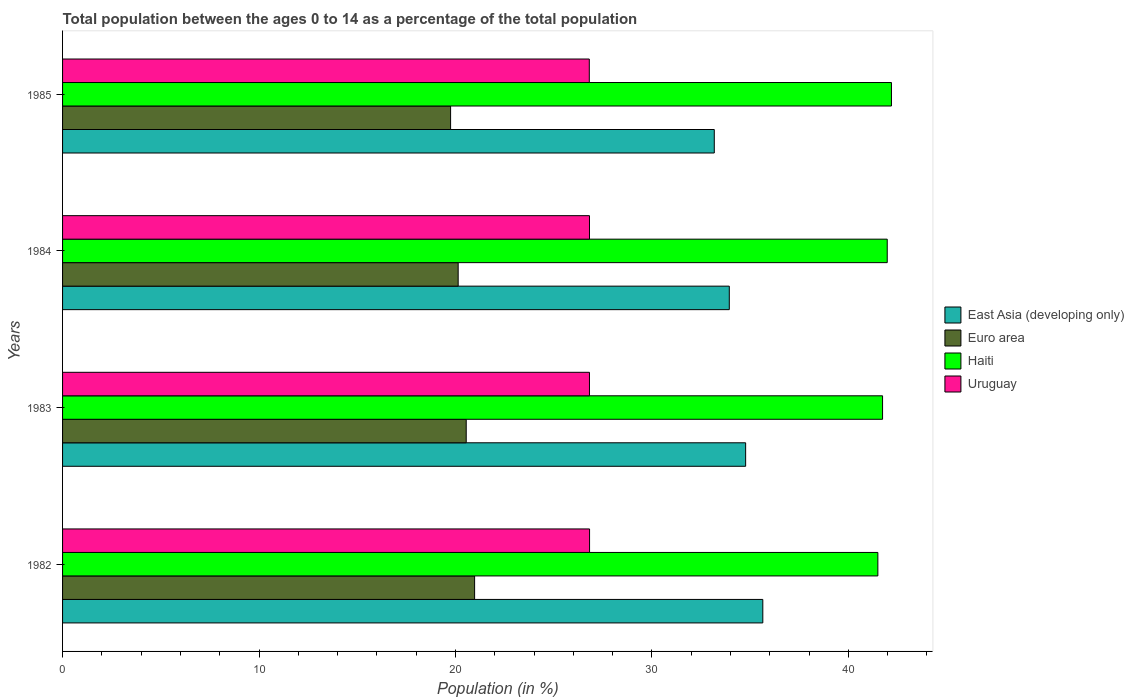How many different coloured bars are there?
Provide a succinct answer. 4. Are the number of bars per tick equal to the number of legend labels?
Your answer should be very brief. Yes. Are the number of bars on each tick of the Y-axis equal?
Offer a very short reply. Yes. How many bars are there on the 3rd tick from the bottom?
Give a very brief answer. 4. In how many cases, is the number of bars for a given year not equal to the number of legend labels?
Your answer should be very brief. 0. What is the percentage of the population ages 0 to 14 in Haiti in 1985?
Give a very brief answer. 42.2. Across all years, what is the maximum percentage of the population ages 0 to 14 in Euro area?
Offer a terse response. 20.98. Across all years, what is the minimum percentage of the population ages 0 to 14 in Uruguay?
Ensure brevity in your answer.  26.81. In which year was the percentage of the population ages 0 to 14 in East Asia (developing only) minimum?
Offer a very short reply. 1985. What is the total percentage of the population ages 0 to 14 in Haiti in the graph?
Your answer should be very brief. 167.42. What is the difference between the percentage of the population ages 0 to 14 in East Asia (developing only) in 1982 and that in 1985?
Your answer should be very brief. 2.47. What is the difference between the percentage of the population ages 0 to 14 in Euro area in 1983 and the percentage of the population ages 0 to 14 in East Asia (developing only) in 1982?
Offer a very short reply. -15.1. What is the average percentage of the population ages 0 to 14 in Uruguay per year?
Provide a short and direct response. 26.82. In the year 1984, what is the difference between the percentage of the population ages 0 to 14 in Euro area and percentage of the population ages 0 to 14 in Haiti?
Offer a very short reply. -21.84. In how many years, is the percentage of the population ages 0 to 14 in East Asia (developing only) greater than 16 ?
Provide a short and direct response. 4. What is the ratio of the percentage of the population ages 0 to 14 in Euro area in 1984 to that in 1985?
Provide a succinct answer. 1.02. What is the difference between the highest and the second highest percentage of the population ages 0 to 14 in East Asia (developing only)?
Your answer should be very brief. 0.87. What is the difference between the highest and the lowest percentage of the population ages 0 to 14 in Euro area?
Give a very brief answer. 1.22. In how many years, is the percentage of the population ages 0 to 14 in East Asia (developing only) greater than the average percentage of the population ages 0 to 14 in East Asia (developing only) taken over all years?
Give a very brief answer. 2. Is the sum of the percentage of the population ages 0 to 14 in Haiti in 1983 and 1985 greater than the maximum percentage of the population ages 0 to 14 in Uruguay across all years?
Offer a terse response. Yes. Is it the case that in every year, the sum of the percentage of the population ages 0 to 14 in East Asia (developing only) and percentage of the population ages 0 to 14 in Euro area is greater than the sum of percentage of the population ages 0 to 14 in Haiti and percentage of the population ages 0 to 14 in Uruguay?
Give a very brief answer. No. What does the 1st bar from the bottom in 1983 represents?
Keep it short and to the point. East Asia (developing only). Is it the case that in every year, the sum of the percentage of the population ages 0 to 14 in Haiti and percentage of the population ages 0 to 14 in Euro area is greater than the percentage of the population ages 0 to 14 in Uruguay?
Provide a short and direct response. Yes. How many bars are there?
Your answer should be compact. 16. What is the difference between two consecutive major ticks on the X-axis?
Your answer should be compact. 10. Does the graph contain any zero values?
Your response must be concise. No. Does the graph contain grids?
Give a very brief answer. No. Where does the legend appear in the graph?
Offer a terse response. Center right. What is the title of the graph?
Keep it short and to the point. Total population between the ages 0 to 14 as a percentage of the total population. Does "Denmark" appear as one of the legend labels in the graph?
Your response must be concise. No. What is the label or title of the X-axis?
Provide a short and direct response. Population (in %). What is the label or title of the Y-axis?
Keep it short and to the point. Years. What is the Population (in %) in East Asia (developing only) in 1982?
Make the answer very short. 35.65. What is the Population (in %) of Euro area in 1982?
Provide a short and direct response. 20.98. What is the Population (in %) of Haiti in 1982?
Give a very brief answer. 41.5. What is the Population (in %) of Uruguay in 1982?
Provide a succinct answer. 26.83. What is the Population (in %) of East Asia (developing only) in 1983?
Provide a short and direct response. 34.77. What is the Population (in %) in Euro area in 1983?
Your response must be concise. 20.55. What is the Population (in %) in Haiti in 1983?
Your answer should be very brief. 41.74. What is the Population (in %) in Uruguay in 1983?
Keep it short and to the point. 26.82. What is the Population (in %) in East Asia (developing only) in 1984?
Make the answer very short. 33.94. What is the Population (in %) of Euro area in 1984?
Your response must be concise. 20.14. What is the Population (in %) of Haiti in 1984?
Make the answer very short. 41.98. What is the Population (in %) of Uruguay in 1984?
Your answer should be very brief. 26.82. What is the Population (in %) in East Asia (developing only) in 1985?
Offer a terse response. 33.18. What is the Population (in %) in Euro area in 1985?
Make the answer very short. 19.75. What is the Population (in %) in Haiti in 1985?
Offer a very short reply. 42.2. What is the Population (in %) in Uruguay in 1985?
Ensure brevity in your answer.  26.81. Across all years, what is the maximum Population (in %) of East Asia (developing only)?
Your answer should be compact. 35.65. Across all years, what is the maximum Population (in %) of Euro area?
Offer a very short reply. 20.98. Across all years, what is the maximum Population (in %) of Haiti?
Your answer should be compact. 42.2. Across all years, what is the maximum Population (in %) in Uruguay?
Offer a terse response. 26.83. Across all years, what is the minimum Population (in %) in East Asia (developing only)?
Keep it short and to the point. 33.18. Across all years, what is the minimum Population (in %) in Euro area?
Provide a short and direct response. 19.75. Across all years, what is the minimum Population (in %) in Haiti?
Your answer should be very brief. 41.5. Across all years, what is the minimum Population (in %) in Uruguay?
Make the answer very short. 26.81. What is the total Population (in %) of East Asia (developing only) in the graph?
Offer a very short reply. 137.54. What is the total Population (in %) of Euro area in the graph?
Make the answer very short. 81.42. What is the total Population (in %) in Haiti in the graph?
Your answer should be compact. 167.42. What is the total Population (in %) in Uruguay in the graph?
Keep it short and to the point. 107.29. What is the difference between the Population (in %) in East Asia (developing only) in 1982 and that in 1983?
Make the answer very short. 0.87. What is the difference between the Population (in %) in Euro area in 1982 and that in 1983?
Provide a short and direct response. 0.43. What is the difference between the Population (in %) of Haiti in 1982 and that in 1983?
Your response must be concise. -0.24. What is the difference between the Population (in %) of Uruguay in 1982 and that in 1983?
Provide a succinct answer. 0.01. What is the difference between the Population (in %) in East Asia (developing only) in 1982 and that in 1984?
Offer a terse response. 1.71. What is the difference between the Population (in %) in Euro area in 1982 and that in 1984?
Keep it short and to the point. 0.84. What is the difference between the Population (in %) of Haiti in 1982 and that in 1984?
Your answer should be very brief. -0.48. What is the difference between the Population (in %) in Uruguay in 1982 and that in 1984?
Your response must be concise. 0. What is the difference between the Population (in %) in East Asia (developing only) in 1982 and that in 1985?
Ensure brevity in your answer.  2.47. What is the difference between the Population (in %) in Euro area in 1982 and that in 1985?
Provide a succinct answer. 1.22. What is the difference between the Population (in %) of Haiti in 1982 and that in 1985?
Provide a short and direct response. -0.69. What is the difference between the Population (in %) of Uruguay in 1982 and that in 1985?
Your response must be concise. 0.01. What is the difference between the Population (in %) of East Asia (developing only) in 1983 and that in 1984?
Keep it short and to the point. 0.83. What is the difference between the Population (in %) in Euro area in 1983 and that in 1984?
Keep it short and to the point. 0.41. What is the difference between the Population (in %) in Haiti in 1983 and that in 1984?
Your answer should be very brief. -0.24. What is the difference between the Population (in %) of Uruguay in 1983 and that in 1984?
Provide a succinct answer. -0. What is the difference between the Population (in %) of East Asia (developing only) in 1983 and that in 1985?
Your response must be concise. 1.6. What is the difference between the Population (in %) of Euro area in 1983 and that in 1985?
Your response must be concise. 0.8. What is the difference between the Population (in %) of Haiti in 1983 and that in 1985?
Offer a very short reply. -0.45. What is the difference between the Population (in %) of Uruguay in 1983 and that in 1985?
Make the answer very short. 0.01. What is the difference between the Population (in %) of East Asia (developing only) in 1984 and that in 1985?
Offer a very short reply. 0.76. What is the difference between the Population (in %) of Euro area in 1984 and that in 1985?
Keep it short and to the point. 0.39. What is the difference between the Population (in %) in Haiti in 1984 and that in 1985?
Provide a short and direct response. -0.21. What is the difference between the Population (in %) in Uruguay in 1984 and that in 1985?
Offer a very short reply. 0.01. What is the difference between the Population (in %) of East Asia (developing only) in 1982 and the Population (in %) of Euro area in 1983?
Make the answer very short. 15.1. What is the difference between the Population (in %) of East Asia (developing only) in 1982 and the Population (in %) of Haiti in 1983?
Give a very brief answer. -6.1. What is the difference between the Population (in %) of East Asia (developing only) in 1982 and the Population (in %) of Uruguay in 1983?
Offer a very short reply. 8.82. What is the difference between the Population (in %) in Euro area in 1982 and the Population (in %) in Haiti in 1983?
Ensure brevity in your answer.  -20.77. What is the difference between the Population (in %) of Euro area in 1982 and the Population (in %) of Uruguay in 1983?
Give a very brief answer. -5.85. What is the difference between the Population (in %) of Haiti in 1982 and the Population (in %) of Uruguay in 1983?
Offer a terse response. 14.68. What is the difference between the Population (in %) in East Asia (developing only) in 1982 and the Population (in %) in Euro area in 1984?
Your answer should be compact. 15.51. What is the difference between the Population (in %) in East Asia (developing only) in 1982 and the Population (in %) in Haiti in 1984?
Your answer should be compact. -6.33. What is the difference between the Population (in %) in East Asia (developing only) in 1982 and the Population (in %) in Uruguay in 1984?
Give a very brief answer. 8.82. What is the difference between the Population (in %) in Euro area in 1982 and the Population (in %) in Haiti in 1984?
Give a very brief answer. -21.01. What is the difference between the Population (in %) in Euro area in 1982 and the Population (in %) in Uruguay in 1984?
Offer a terse response. -5.85. What is the difference between the Population (in %) in Haiti in 1982 and the Population (in %) in Uruguay in 1984?
Make the answer very short. 14.68. What is the difference between the Population (in %) in East Asia (developing only) in 1982 and the Population (in %) in Euro area in 1985?
Your answer should be compact. 15.89. What is the difference between the Population (in %) of East Asia (developing only) in 1982 and the Population (in %) of Haiti in 1985?
Your answer should be very brief. -6.55. What is the difference between the Population (in %) in East Asia (developing only) in 1982 and the Population (in %) in Uruguay in 1985?
Provide a short and direct response. 8.83. What is the difference between the Population (in %) of Euro area in 1982 and the Population (in %) of Haiti in 1985?
Provide a short and direct response. -21.22. What is the difference between the Population (in %) of Euro area in 1982 and the Population (in %) of Uruguay in 1985?
Your answer should be very brief. -5.84. What is the difference between the Population (in %) in Haiti in 1982 and the Population (in %) in Uruguay in 1985?
Ensure brevity in your answer.  14.69. What is the difference between the Population (in %) of East Asia (developing only) in 1983 and the Population (in %) of Euro area in 1984?
Provide a short and direct response. 14.63. What is the difference between the Population (in %) of East Asia (developing only) in 1983 and the Population (in %) of Haiti in 1984?
Offer a very short reply. -7.21. What is the difference between the Population (in %) in East Asia (developing only) in 1983 and the Population (in %) in Uruguay in 1984?
Make the answer very short. 7.95. What is the difference between the Population (in %) of Euro area in 1983 and the Population (in %) of Haiti in 1984?
Your response must be concise. -21.43. What is the difference between the Population (in %) of Euro area in 1983 and the Population (in %) of Uruguay in 1984?
Your answer should be very brief. -6.28. What is the difference between the Population (in %) in Haiti in 1983 and the Population (in %) in Uruguay in 1984?
Make the answer very short. 14.92. What is the difference between the Population (in %) in East Asia (developing only) in 1983 and the Population (in %) in Euro area in 1985?
Give a very brief answer. 15.02. What is the difference between the Population (in %) in East Asia (developing only) in 1983 and the Population (in %) in Haiti in 1985?
Make the answer very short. -7.42. What is the difference between the Population (in %) in East Asia (developing only) in 1983 and the Population (in %) in Uruguay in 1985?
Your answer should be very brief. 7.96. What is the difference between the Population (in %) of Euro area in 1983 and the Population (in %) of Haiti in 1985?
Your answer should be very brief. -21.65. What is the difference between the Population (in %) in Euro area in 1983 and the Population (in %) in Uruguay in 1985?
Your response must be concise. -6.27. What is the difference between the Population (in %) in Haiti in 1983 and the Population (in %) in Uruguay in 1985?
Keep it short and to the point. 14.93. What is the difference between the Population (in %) in East Asia (developing only) in 1984 and the Population (in %) in Euro area in 1985?
Provide a succinct answer. 14.19. What is the difference between the Population (in %) in East Asia (developing only) in 1984 and the Population (in %) in Haiti in 1985?
Give a very brief answer. -8.25. What is the difference between the Population (in %) of East Asia (developing only) in 1984 and the Population (in %) of Uruguay in 1985?
Offer a terse response. 7.13. What is the difference between the Population (in %) in Euro area in 1984 and the Population (in %) in Haiti in 1985?
Offer a very short reply. -22.06. What is the difference between the Population (in %) in Euro area in 1984 and the Population (in %) in Uruguay in 1985?
Give a very brief answer. -6.68. What is the difference between the Population (in %) of Haiti in 1984 and the Population (in %) of Uruguay in 1985?
Ensure brevity in your answer.  15.17. What is the average Population (in %) in East Asia (developing only) per year?
Offer a terse response. 34.38. What is the average Population (in %) in Euro area per year?
Provide a succinct answer. 20.35. What is the average Population (in %) in Haiti per year?
Offer a very short reply. 41.86. What is the average Population (in %) in Uruguay per year?
Your response must be concise. 26.82. In the year 1982, what is the difference between the Population (in %) in East Asia (developing only) and Population (in %) in Euro area?
Provide a succinct answer. 14.67. In the year 1982, what is the difference between the Population (in %) of East Asia (developing only) and Population (in %) of Haiti?
Keep it short and to the point. -5.86. In the year 1982, what is the difference between the Population (in %) in East Asia (developing only) and Population (in %) in Uruguay?
Keep it short and to the point. 8.82. In the year 1982, what is the difference between the Population (in %) of Euro area and Population (in %) of Haiti?
Your answer should be compact. -20.53. In the year 1982, what is the difference between the Population (in %) of Euro area and Population (in %) of Uruguay?
Provide a succinct answer. -5.85. In the year 1982, what is the difference between the Population (in %) of Haiti and Population (in %) of Uruguay?
Provide a short and direct response. 14.68. In the year 1983, what is the difference between the Population (in %) of East Asia (developing only) and Population (in %) of Euro area?
Your answer should be very brief. 14.22. In the year 1983, what is the difference between the Population (in %) in East Asia (developing only) and Population (in %) in Haiti?
Offer a very short reply. -6.97. In the year 1983, what is the difference between the Population (in %) of East Asia (developing only) and Population (in %) of Uruguay?
Make the answer very short. 7.95. In the year 1983, what is the difference between the Population (in %) in Euro area and Population (in %) in Haiti?
Ensure brevity in your answer.  -21.19. In the year 1983, what is the difference between the Population (in %) of Euro area and Population (in %) of Uruguay?
Make the answer very short. -6.27. In the year 1983, what is the difference between the Population (in %) in Haiti and Population (in %) in Uruguay?
Give a very brief answer. 14.92. In the year 1984, what is the difference between the Population (in %) in East Asia (developing only) and Population (in %) in Euro area?
Give a very brief answer. 13.8. In the year 1984, what is the difference between the Population (in %) of East Asia (developing only) and Population (in %) of Haiti?
Your answer should be very brief. -8.04. In the year 1984, what is the difference between the Population (in %) in East Asia (developing only) and Population (in %) in Uruguay?
Offer a very short reply. 7.12. In the year 1984, what is the difference between the Population (in %) of Euro area and Population (in %) of Haiti?
Provide a succinct answer. -21.84. In the year 1984, what is the difference between the Population (in %) in Euro area and Population (in %) in Uruguay?
Your response must be concise. -6.68. In the year 1984, what is the difference between the Population (in %) in Haiti and Population (in %) in Uruguay?
Offer a very short reply. 15.16. In the year 1985, what is the difference between the Population (in %) of East Asia (developing only) and Population (in %) of Euro area?
Your answer should be compact. 13.42. In the year 1985, what is the difference between the Population (in %) in East Asia (developing only) and Population (in %) in Haiti?
Make the answer very short. -9.02. In the year 1985, what is the difference between the Population (in %) of East Asia (developing only) and Population (in %) of Uruguay?
Your response must be concise. 6.36. In the year 1985, what is the difference between the Population (in %) in Euro area and Population (in %) in Haiti?
Your response must be concise. -22.44. In the year 1985, what is the difference between the Population (in %) of Euro area and Population (in %) of Uruguay?
Keep it short and to the point. -7.06. In the year 1985, what is the difference between the Population (in %) of Haiti and Population (in %) of Uruguay?
Your answer should be very brief. 15.38. What is the ratio of the Population (in %) in East Asia (developing only) in 1982 to that in 1983?
Give a very brief answer. 1.03. What is the ratio of the Population (in %) in Euro area in 1982 to that in 1983?
Give a very brief answer. 1.02. What is the ratio of the Population (in %) in Haiti in 1982 to that in 1983?
Make the answer very short. 0.99. What is the ratio of the Population (in %) of East Asia (developing only) in 1982 to that in 1984?
Offer a very short reply. 1.05. What is the ratio of the Population (in %) in Euro area in 1982 to that in 1984?
Your response must be concise. 1.04. What is the ratio of the Population (in %) in Haiti in 1982 to that in 1984?
Ensure brevity in your answer.  0.99. What is the ratio of the Population (in %) of East Asia (developing only) in 1982 to that in 1985?
Provide a succinct answer. 1.07. What is the ratio of the Population (in %) in Euro area in 1982 to that in 1985?
Offer a very short reply. 1.06. What is the ratio of the Population (in %) in Haiti in 1982 to that in 1985?
Give a very brief answer. 0.98. What is the ratio of the Population (in %) in Uruguay in 1982 to that in 1985?
Your answer should be very brief. 1. What is the ratio of the Population (in %) in East Asia (developing only) in 1983 to that in 1984?
Offer a very short reply. 1.02. What is the ratio of the Population (in %) in Euro area in 1983 to that in 1984?
Offer a terse response. 1.02. What is the ratio of the Population (in %) of Uruguay in 1983 to that in 1984?
Ensure brevity in your answer.  1. What is the ratio of the Population (in %) of East Asia (developing only) in 1983 to that in 1985?
Ensure brevity in your answer.  1.05. What is the ratio of the Population (in %) of Euro area in 1983 to that in 1985?
Your answer should be compact. 1.04. What is the ratio of the Population (in %) in Haiti in 1983 to that in 1985?
Your answer should be compact. 0.99. What is the ratio of the Population (in %) of East Asia (developing only) in 1984 to that in 1985?
Offer a terse response. 1.02. What is the ratio of the Population (in %) of Euro area in 1984 to that in 1985?
Your answer should be very brief. 1.02. What is the ratio of the Population (in %) of Haiti in 1984 to that in 1985?
Offer a very short reply. 0.99. What is the ratio of the Population (in %) of Uruguay in 1984 to that in 1985?
Your response must be concise. 1. What is the difference between the highest and the second highest Population (in %) of East Asia (developing only)?
Provide a short and direct response. 0.87. What is the difference between the highest and the second highest Population (in %) of Euro area?
Your answer should be compact. 0.43. What is the difference between the highest and the second highest Population (in %) in Haiti?
Your answer should be very brief. 0.21. What is the difference between the highest and the second highest Population (in %) in Uruguay?
Ensure brevity in your answer.  0. What is the difference between the highest and the lowest Population (in %) in East Asia (developing only)?
Give a very brief answer. 2.47. What is the difference between the highest and the lowest Population (in %) in Euro area?
Keep it short and to the point. 1.22. What is the difference between the highest and the lowest Population (in %) in Haiti?
Your answer should be compact. 0.69. What is the difference between the highest and the lowest Population (in %) in Uruguay?
Provide a short and direct response. 0.01. 